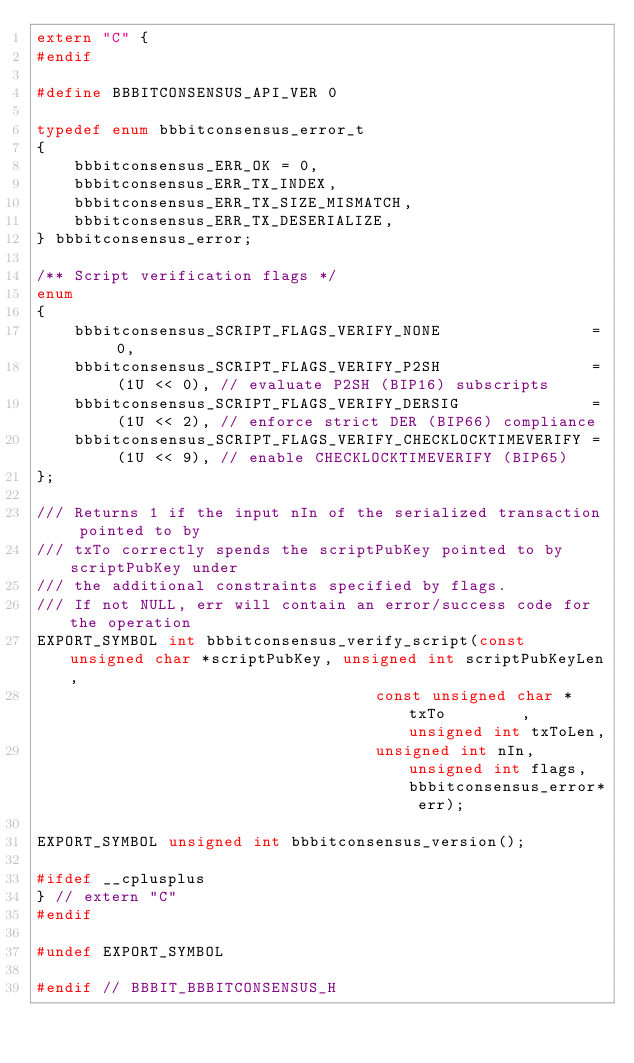Convert code to text. <code><loc_0><loc_0><loc_500><loc_500><_C_>extern "C" {
#endif

#define BBBITCONSENSUS_API_VER 0

typedef enum bbbitconsensus_error_t
{
    bbbitconsensus_ERR_OK = 0,
    bbbitconsensus_ERR_TX_INDEX,
    bbbitconsensus_ERR_TX_SIZE_MISMATCH,
    bbbitconsensus_ERR_TX_DESERIALIZE,
} bbbitconsensus_error;

/** Script verification flags */
enum
{
    bbbitconsensus_SCRIPT_FLAGS_VERIFY_NONE                = 0,
    bbbitconsensus_SCRIPT_FLAGS_VERIFY_P2SH                = (1U << 0), // evaluate P2SH (BIP16) subscripts
    bbbitconsensus_SCRIPT_FLAGS_VERIFY_DERSIG              = (1U << 2), // enforce strict DER (BIP66) compliance
    bbbitconsensus_SCRIPT_FLAGS_VERIFY_CHECKLOCKTIMEVERIFY = (1U << 9), // enable CHECKLOCKTIMEVERIFY (BIP65)
};

/// Returns 1 if the input nIn of the serialized transaction pointed to by
/// txTo correctly spends the scriptPubKey pointed to by scriptPubKey under
/// the additional constraints specified by flags.
/// If not NULL, err will contain an error/success code for the operation
EXPORT_SYMBOL int bbbitconsensus_verify_script(const unsigned char *scriptPubKey, unsigned int scriptPubKeyLen,
                                    const unsigned char *txTo        , unsigned int txToLen,
                                    unsigned int nIn, unsigned int flags, bbbitconsensus_error* err);

EXPORT_SYMBOL unsigned int bbbitconsensus_version();

#ifdef __cplusplus
} // extern "C"
#endif

#undef EXPORT_SYMBOL

#endif // BBBIT_BBBITCONSENSUS_H
</code> 